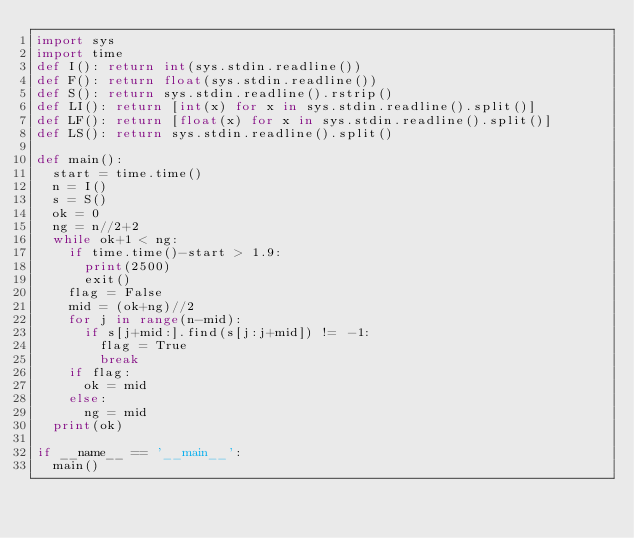Convert code to text. <code><loc_0><loc_0><loc_500><loc_500><_Python_>import sys
import time
def I(): return int(sys.stdin.readline())
def F(): return float(sys.stdin.readline())
def S(): return sys.stdin.readline().rstrip()
def LI(): return [int(x) for x in sys.stdin.readline().split()]
def LF(): return [float(x) for x in sys.stdin.readline().split()]
def LS(): return sys.stdin.readline().split()

def main():
  start = time.time()
  n = I()
  s = S()
  ok = 0
  ng = n//2+2
  while ok+1 < ng:
    if time.time()-start > 1.9:
      print(2500)
      exit()
    flag = False
    mid = (ok+ng)//2
    for j in range(n-mid):
      if s[j+mid:].find(s[j:j+mid]) != -1:
        flag = True
        break
    if flag:
      ok = mid
    else:
      ng = mid
  print(ok)

if __name__ == '__main__':
  main()</code> 